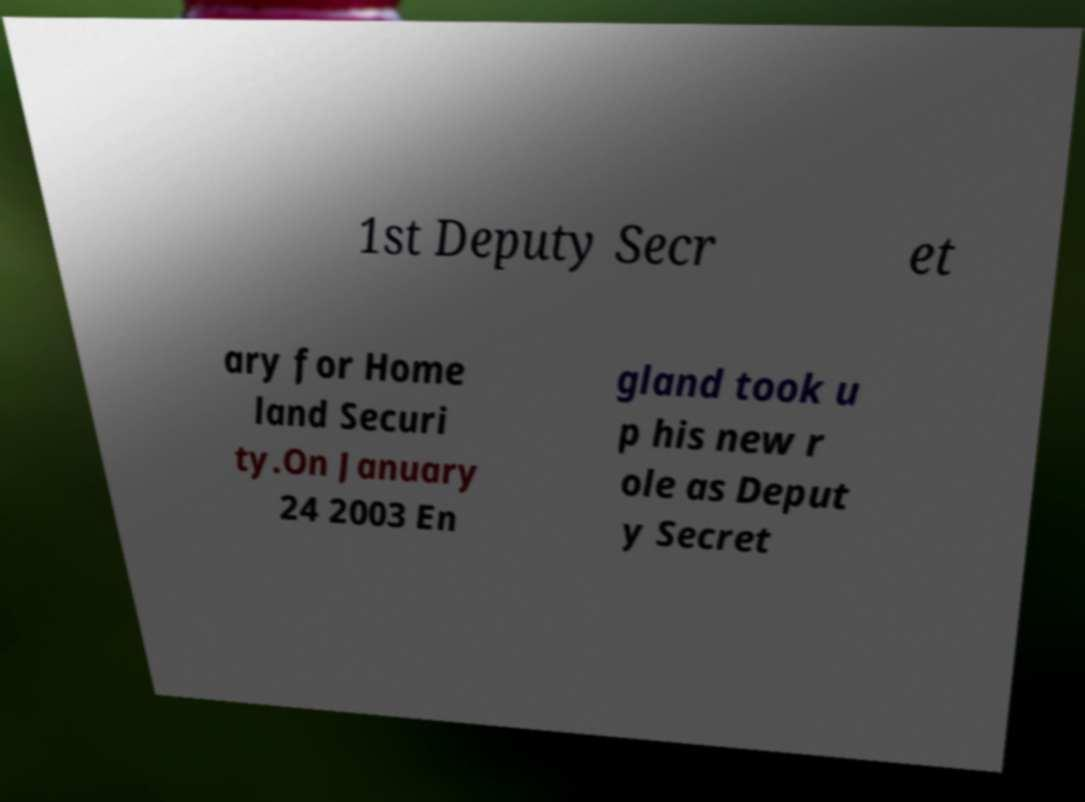There's text embedded in this image that I need extracted. Can you transcribe it verbatim? 1st Deputy Secr et ary for Home land Securi ty.On January 24 2003 En gland took u p his new r ole as Deput y Secret 